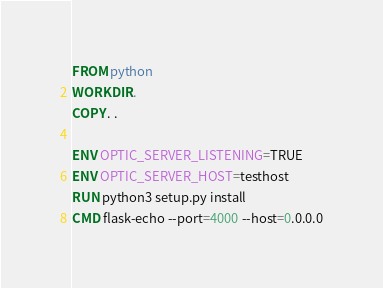<code> <loc_0><loc_0><loc_500><loc_500><_Dockerfile_>FROM python
WORKDIR .
COPY . .

ENV OPTIC_SERVER_LISTENING=TRUE
ENV OPTIC_SERVER_HOST=testhost
RUN python3 setup.py install
CMD flask-echo --port=4000 --host=0.0.0.0
</code> 